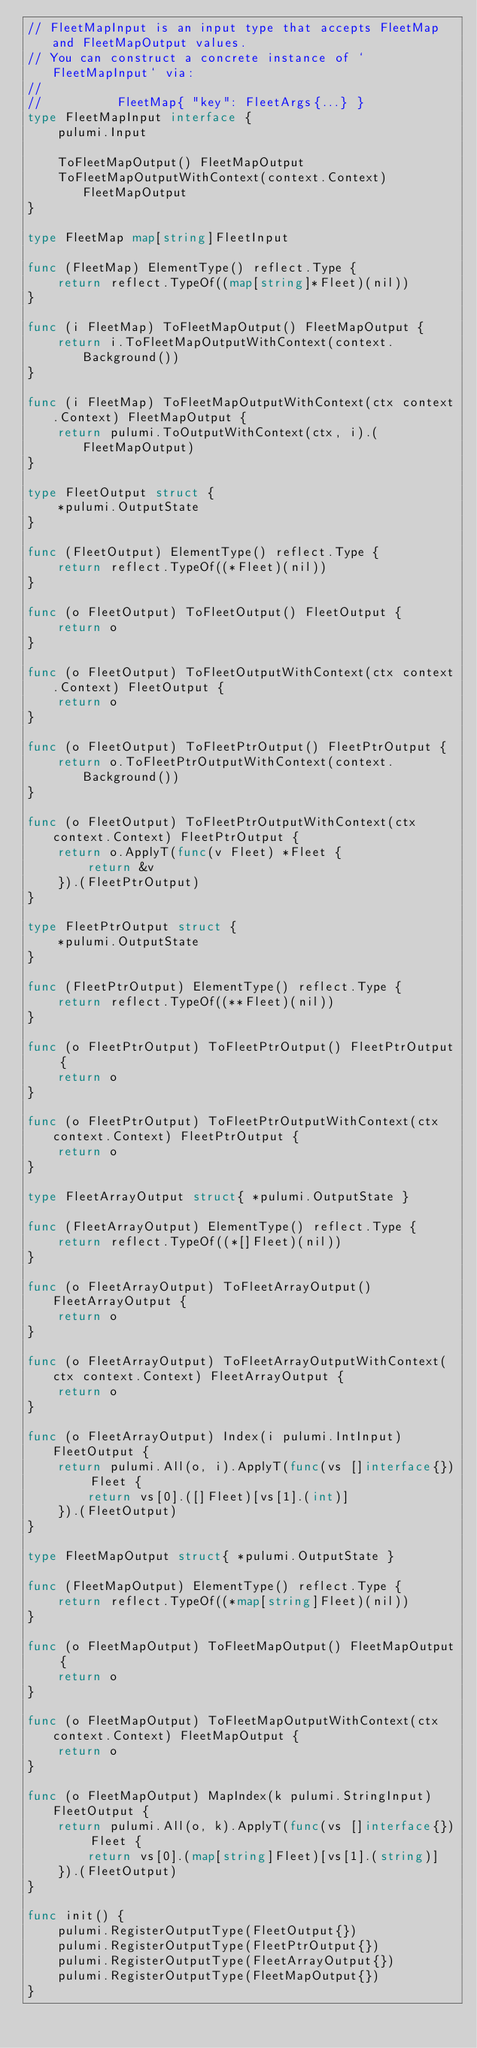<code> <loc_0><loc_0><loc_500><loc_500><_Go_>// FleetMapInput is an input type that accepts FleetMap and FleetMapOutput values.
// You can construct a concrete instance of `FleetMapInput` via:
//
//          FleetMap{ "key": FleetArgs{...} }
type FleetMapInput interface {
	pulumi.Input

	ToFleetMapOutput() FleetMapOutput
	ToFleetMapOutputWithContext(context.Context) FleetMapOutput
}

type FleetMap map[string]FleetInput

func (FleetMap) ElementType() reflect.Type {
	return reflect.TypeOf((map[string]*Fleet)(nil))
}

func (i FleetMap) ToFleetMapOutput() FleetMapOutput {
	return i.ToFleetMapOutputWithContext(context.Background())
}

func (i FleetMap) ToFleetMapOutputWithContext(ctx context.Context) FleetMapOutput {
	return pulumi.ToOutputWithContext(ctx, i).(FleetMapOutput)
}

type FleetOutput struct {
	*pulumi.OutputState
}

func (FleetOutput) ElementType() reflect.Type {
	return reflect.TypeOf((*Fleet)(nil))
}

func (o FleetOutput) ToFleetOutput() FleetOutput {
	return o
}

func (o FleetOutput) ToFleetOutputWithContext(ctx context.Context) FleetOutput {
	return o
}

func (o FleetOutput) ToFleetPtrOutput() FleetPtrOutput {
	return o.ToFleetPtrOutputWithContext(context.Background())
}

func (o FleetOutput) ToFleetPtrOutputWithContext(ctx context.Context) FleetPtrOutput {
	return o.ApplyT(func(v Fleet) *Fleet {
		return &v
	}).(FleetPtrOutput)
}

type FleetPtrOutput struct {
	*pulumi.OutputState
}

func (FleetPtrOutput) ElementType() reflect.Type {
	return reflect.TypeOf((**Fleet)(nil))
}

func (o FleetPtrOutput) ToFleetPtrOutput() FleetPtrOutput {
	return o
}

func (o FleetPtrOutput) ToFleetPtrOutputWithContext(ctx context.Context) FleetPtrOutput {
	return o
}

type FleetArrayOutput struct{ *pulumi.OutputState }

func (FleetArrayOutput) ElementType() reflect.Type {
	return reflect.TypeOf((*[]Fleet)(nil))
}

func (o FleetArrayOutput) ToFleetArrayOutput() FleetArrayOutput {
	return o
}

func (o FleetArrayOutput) ToFleetArrayOutputWithContext(ctx context.Context) FleetArrayOutput {
	return o
}

func (o FleetArrayOutput) Index(i pulumi.IntInput) FleetOutput {
	return pulumi.All(o, i).ApplyT(func(vs []interface{}) Fleet {
		return vs[0].([]Fleet)[vs[1].(int)]
	}).(FleetOutput)
}

type FleetMapOutput struct{ *pulumi.OutputState }

func (FleetMapOutput) ElementType() reflect.Type {
	return reflect.TypeOf((*map[string]Fleet)(nil))
}

func (o FleetMapOutput) ToFleetMapOutput() FleetMapOutput {
	return o
}

func (o FleetMapOutput) ToFleetMapOutputWithContext(ctx context.Context) FleetMapOutput {
	return o
}

func (o FleetMapOutput) MapIndex(k pulumi.StringInput) FleetOutput {
	return pulumi.All(o, k).ApplyT(func(vs []interface{}) Fleet {
		return vs[0].(map[string]Fleet)[vs[1].(string)]
	}).(FleetOutput)
}

func init() {
	pulumi.RegisterOutputType(FleetOutput{})
	pulumi.RegisterOutputType(FleetPtrOutput{})
	pulumi.RegisterOutputType(FleetArrayOutput{})
	pulumi.RegisterOutputType(FleetMapOutput{})
}
</code> 